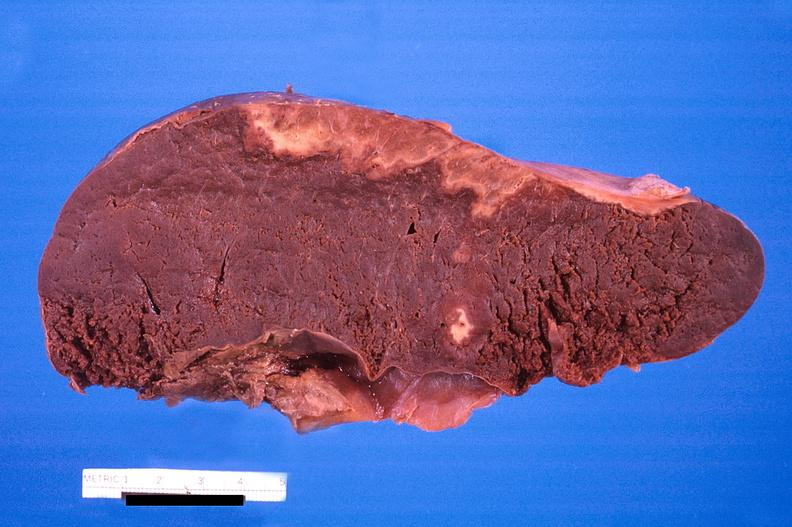where is this part in?
Answer the question using a single word or phrase. Spleen 